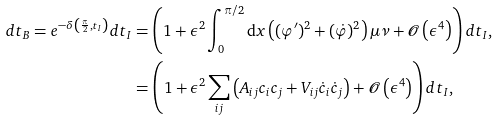<formula> <loc_0><loc_0><loc_500><loc_500>d t _ { B } = e ^ { - \delta \left ( \frac { \pi } { 2 } , t _ { I } \right ) } d t _ { I } & = \left ( 1 + \epsilon ^ { 2 } \int _ { 0 } ^ { \pi / 2 } \text {d} x \left ( ( \varphi ^ { \prime } ) ^ { 2 } + ( \dot { \varphi } ) ^ { 2 } \right ) \mu \nu + \mathcal { O } \left ( \epsilon ^ { 4 } \right ) \right ) d t _ { I } , \\ & = \left ( 1 + \epsilon ^ { 2 } \sum _ { i j } \left ( A _ { i j } c _ { i } c _ { j } + V _ { i j } \dot { c } _ { i } \dot { c } _ { j } \right ) + \mathcal { O } \left ( \epsilon ^ { 4 } \right ) \right ) d t _ { I } ,</formula> 